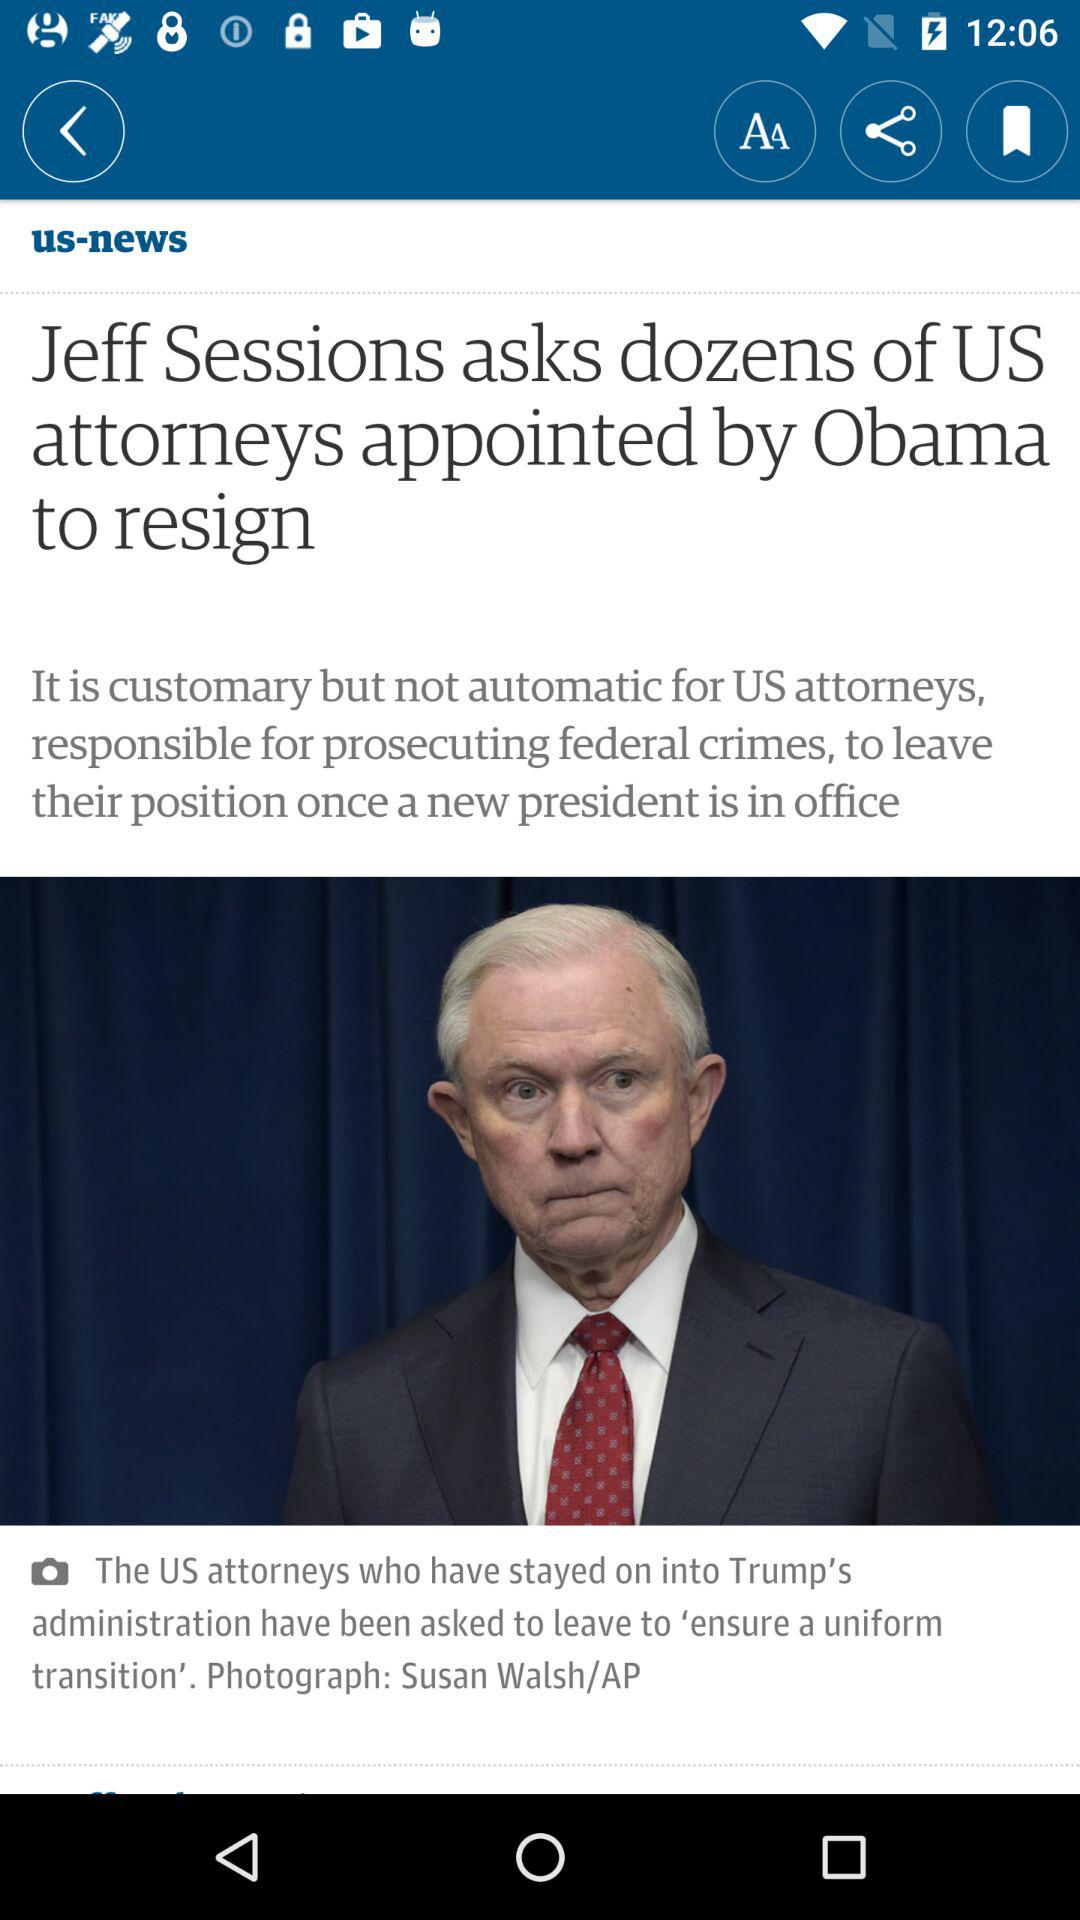What did Jeff Sessions ask the US attorneys appointed by Obama? Jeff Sessions asked the US attorneys appointed by Obama to resign. 